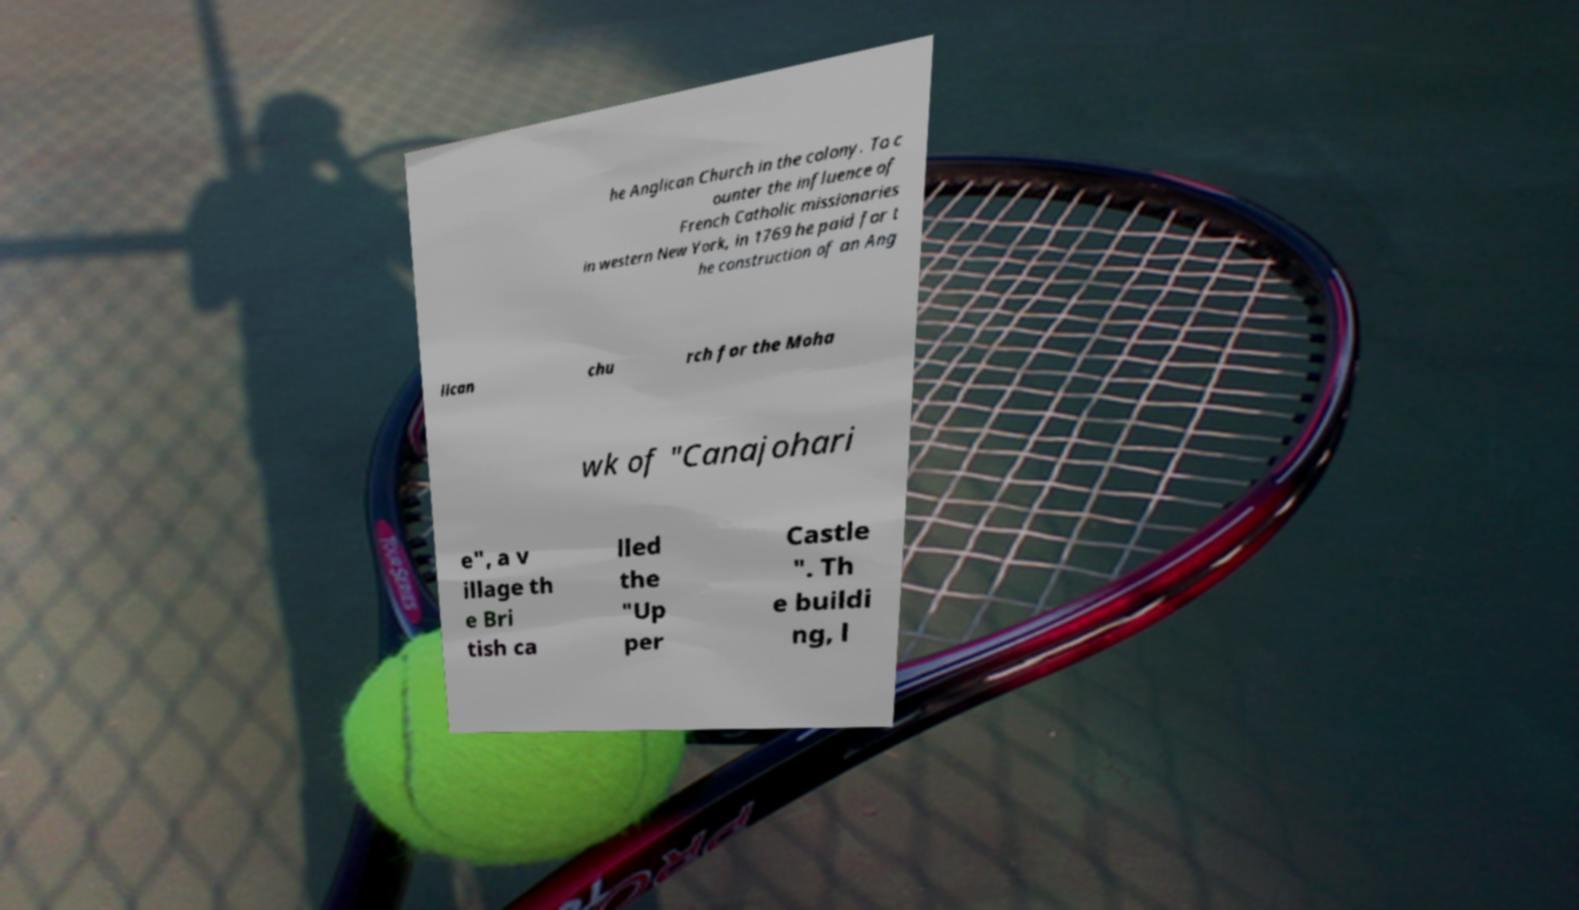What messages or text are displayed in this image? I need them in a readable, typed format. he Anglican Church in the colony. To c ounter the influence of French Catholic missionaries in western New York, in 1769 he paid for t he construction of an Ang lican chu rch for the Moha wk of "Canajohari e", a v illage th e Bri tish ca lled the "Up per Castle ". Th e buildi ng, l 